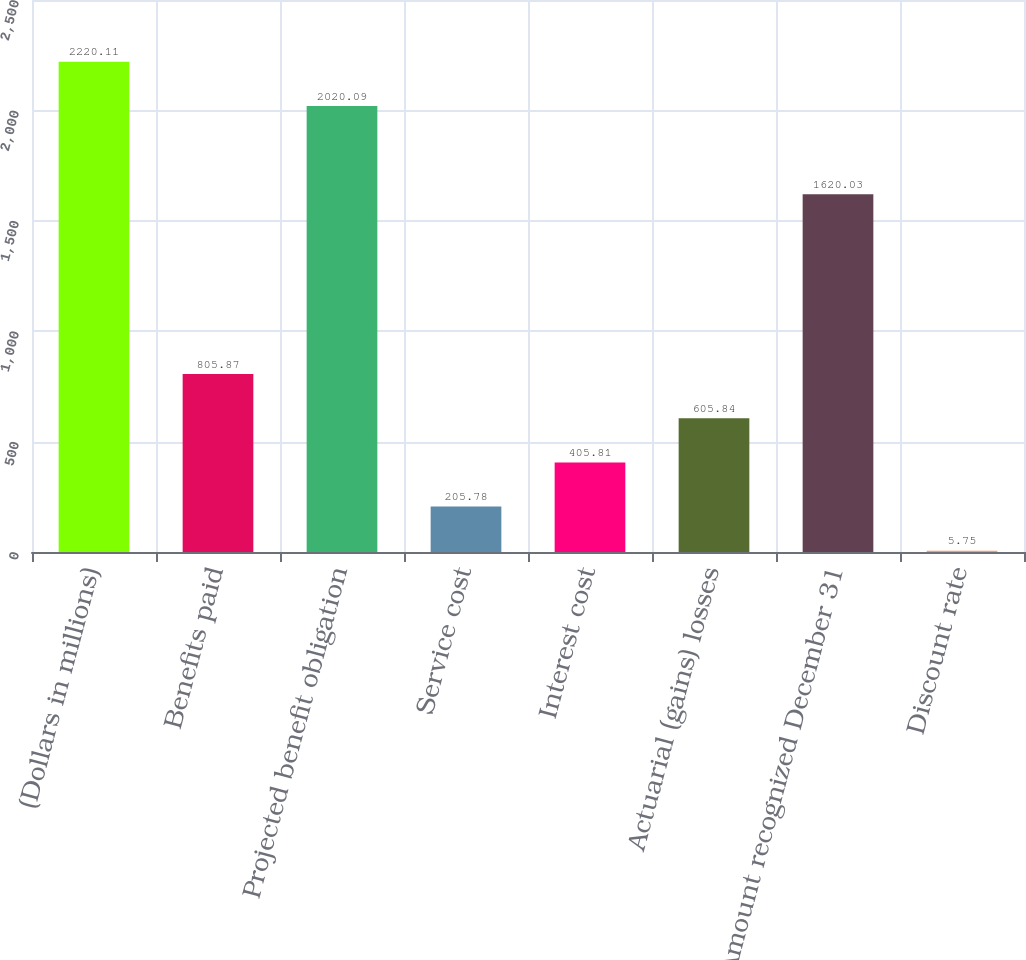Convert chart. <chart><loc_0><loc_0><loc_500><loc_500><bar_chart><fcel>(Dollars in millions)<fcel>Benefits paid<fcel>Projected benefit obligation<fcel>Service cost<fcel>Interest cost<fcel>Actuarial (gains) losses<fcel>Amount recognized December 31<fcel>Discount rate<nl><fcel>2220.11<fcel>805.87<fcel>2020.09<fcel>205.78<fcel>405.81<fcel>605.84<fcel>1620.03<fcel>5.75<nl></chart> 